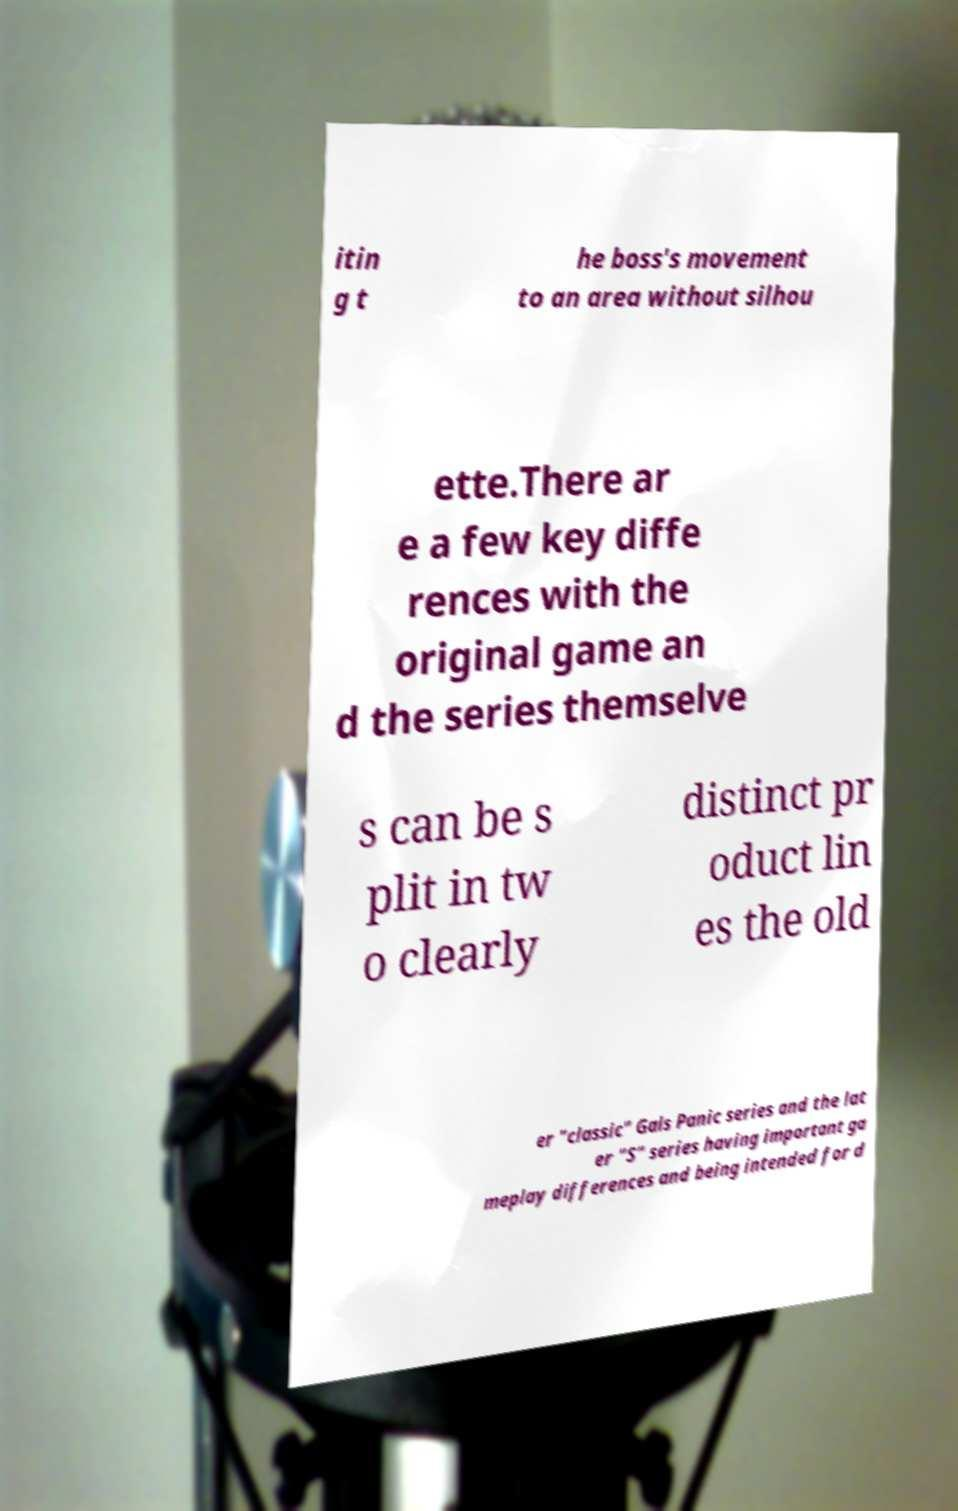Please read and relay the text visible in this image. What does it say? itin g t he boss's movement to an area without silhou ette.There ar e a few key diffe rences with the original game an d the series themselve s can be s plit in tw o clearly distinct pr oduct lin es the old er "classic" Gals Panic series and the lat er "S" series having important ga meplay differences and being intended for d 